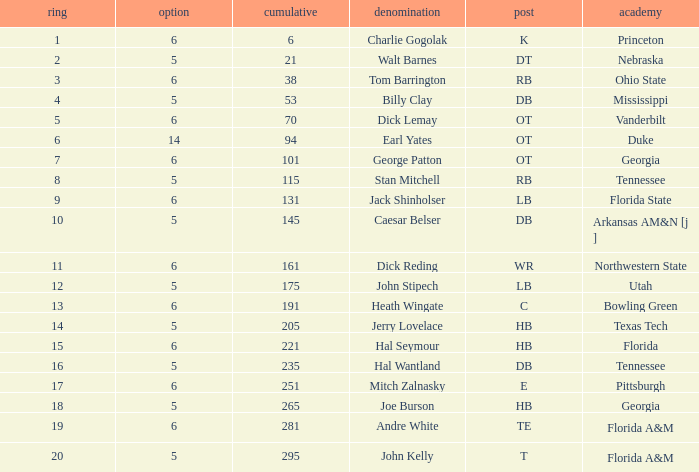What is the highest Pick, when Round is greater than 15, and when College is "Tennessee"? 5.0. 